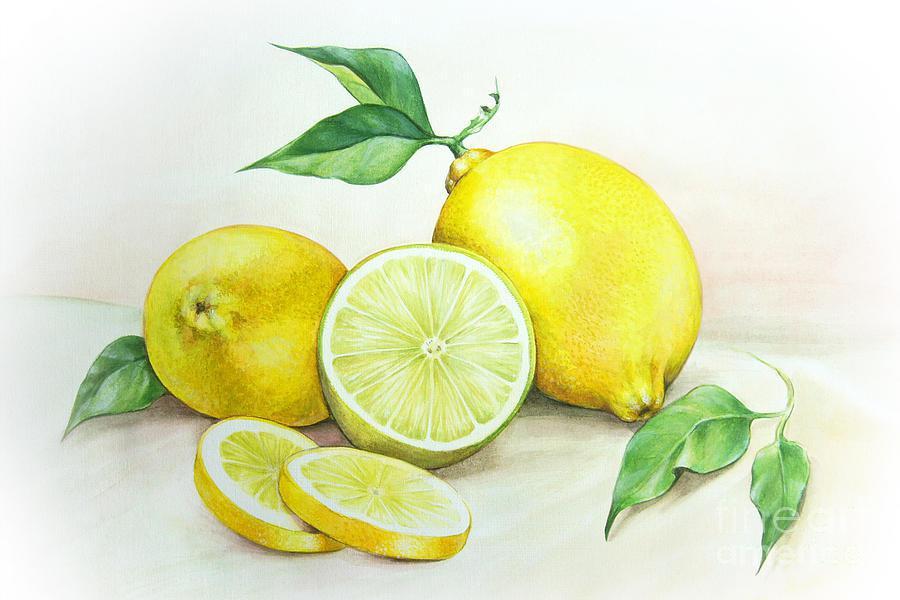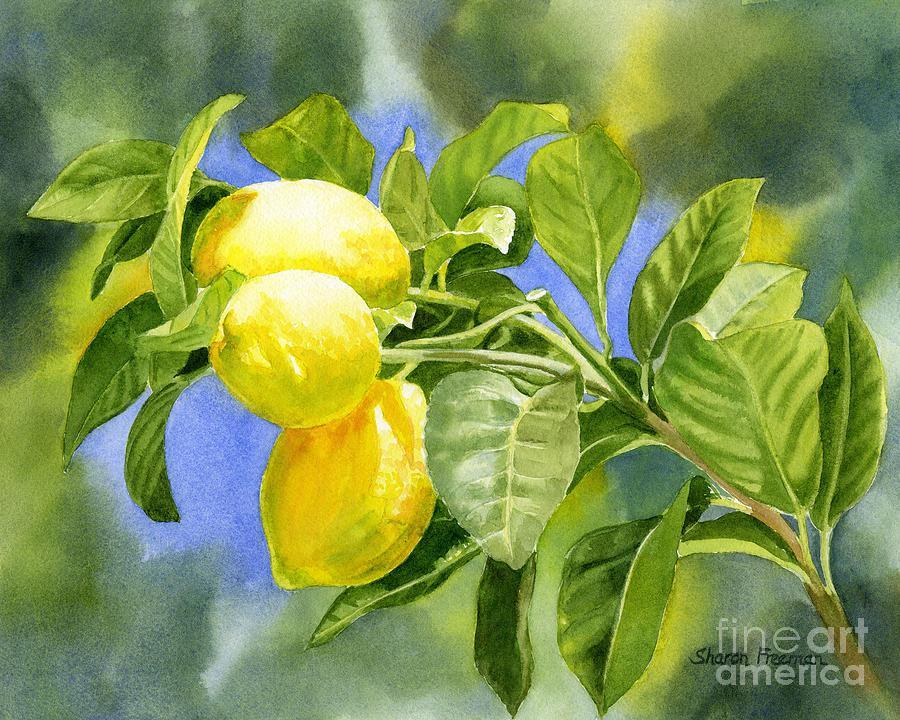The first image is the image on the left, the second image is the image on the right. For the images displayed, is the sentence "Each image includes a whole yellow fruit and a green leaf, one image includes a half-section of fruit, and no image shows unpicked fruit growing on a branch." factually correct? Answer yes or no. No. The first image is the image on the left, the second image is the image on the right. Evaluate the accuracy of this statement regarding the images: "A stem and leaves are attached to a single lemon, while in a second image a lemon segment is beside one or more whole lemons.". Is it true? Answer yes or no. No. 